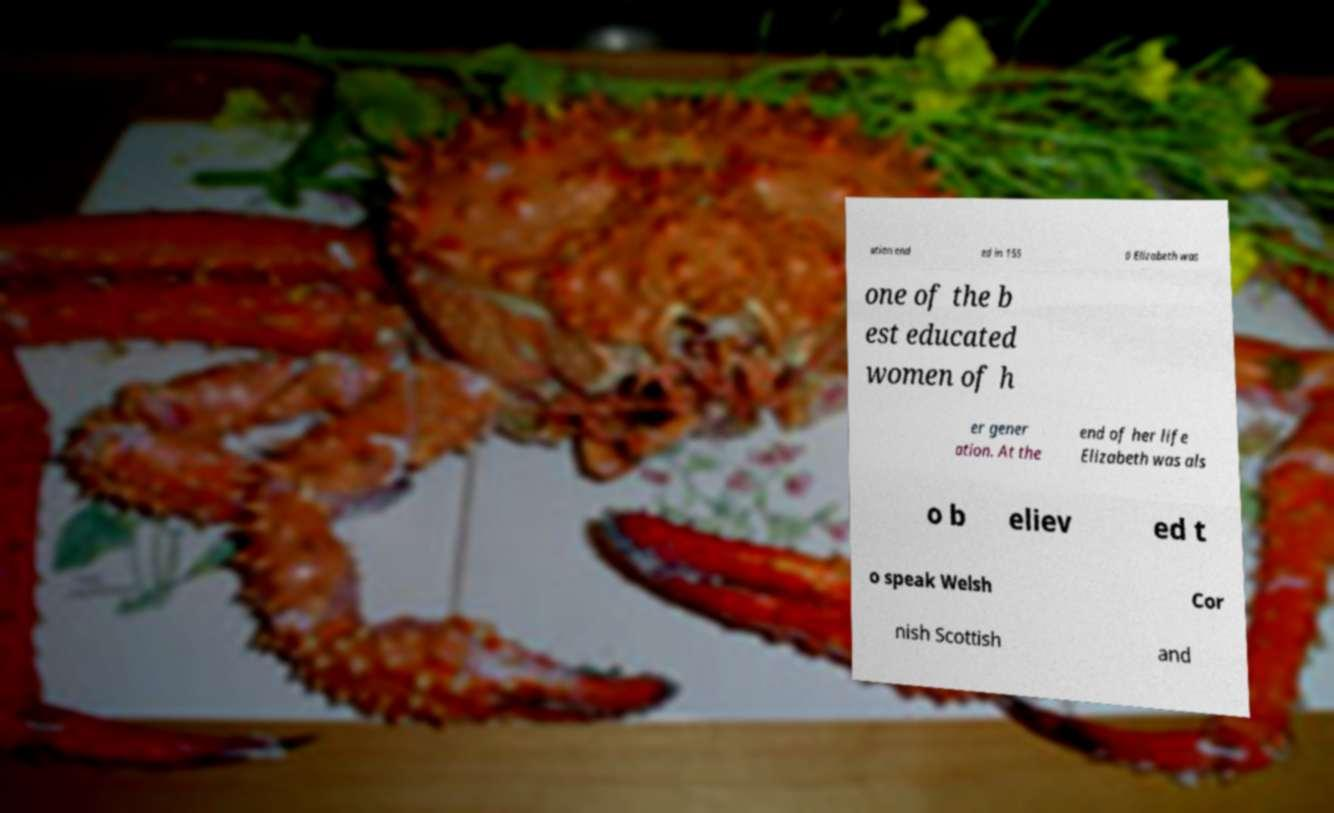Can you accurately transcribe the text from the provided image for me? ation end ed in 155 0 Elizabeth was one of the b est educated women of h er gener ation. At the end of her life Elizabeth was als o b eliev ed t o speak Welsh Cor nish Scottish and 